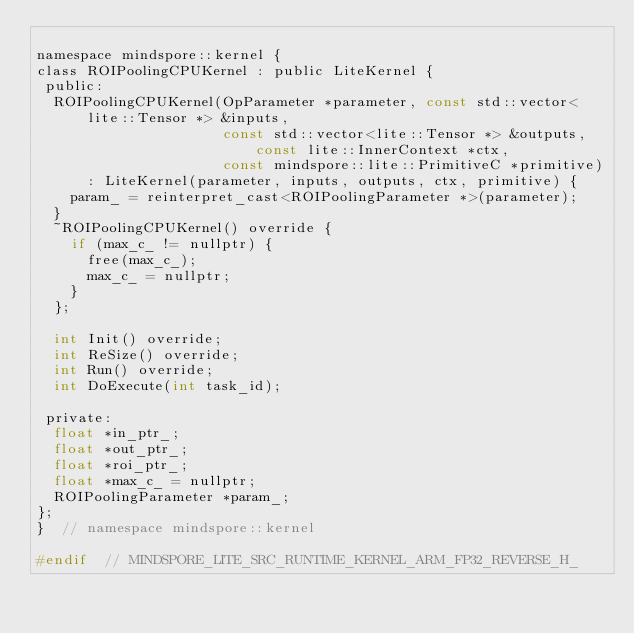<code> <loc_0><loc_0><loc_500><loc_500><_C_>
namespace mindspore::kernel {
class ROIPoolingCPUKernel : public LiteKernel {
 public:
  ROIPoolingCPUKernel(OpParameter *parameter, const std::vector<lite::Tensor *> &inputs,
                      const std::vector<lite::Tensor *> &outputs, const lite::InnerContext *ctx,
                      const mindspore::lite::PrimitiveC *primitive)
      : LiteKernel(parameter, inputs, outputs, ctx, primitive) {
    param_ = reinterpret_cast<ROIPoolingParameter *>(parameter);
  }
  ~ROIPoolingCPUKernel() override {
    if (max_c_ != nullptr) {
      free(max_c_);
      max_c_ = nullptr;
    }
  };

  int Init() override;
  int ReSize() override;
  int Run() override;
  int DoExecute(int task_id);

 private:
  float *in_ptr_;
  float *out_ptr_;
  float *roi_ptr_;
  float *max_c_ = nullptr;
  ROIPoolingParameter *param_;
};
}  // namespace mindspore::kernel

#endif  // MINDSPORE_LITE_SRC_RUNTIME_KERNEL_ARM_FP32_REVERSE_H_
</code> 